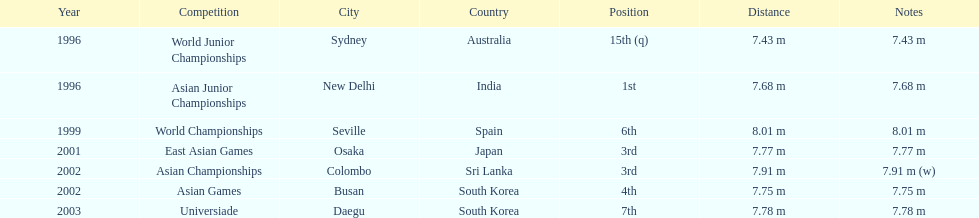How many competitions did he place in the top three? 3. Give me the full table as a dictionary. {'header': ['Year', 'Competition', 'City', 'Country', 'Position', 'Distance', 'Notes'], 'rows': [['1996', 'World Junior Championships', 'Sydney', 'Australia', '15th (q)', '7.43 m', '7.43 m'], ['1996', 'Asian Junior Championships', 'New Delhi', 'India', '1st', '7.68 m', '7.68 m'], ['1999', 'World Championships', 'Seville', 'Spain', '6th', '8.01 m', '8.01 m'], ['2001', 'East Asian Games', 'Osaka', 'Japan', '3rd', '7.77 m', '7.77 m'], ['2002', 'Asian Championships', 'Colombo', 'Sri Lanka', '3rd', '7.91 m', '7.91 m (w)'], ['2002', 'Asian Games', 'Busan', 'South Korea', '4th', '7.75 m', '7.75 m'], ['2003', 'Universiade', 'Daegu', 'South Korea', '7th', '7.78 m', '7.78 m']]} 